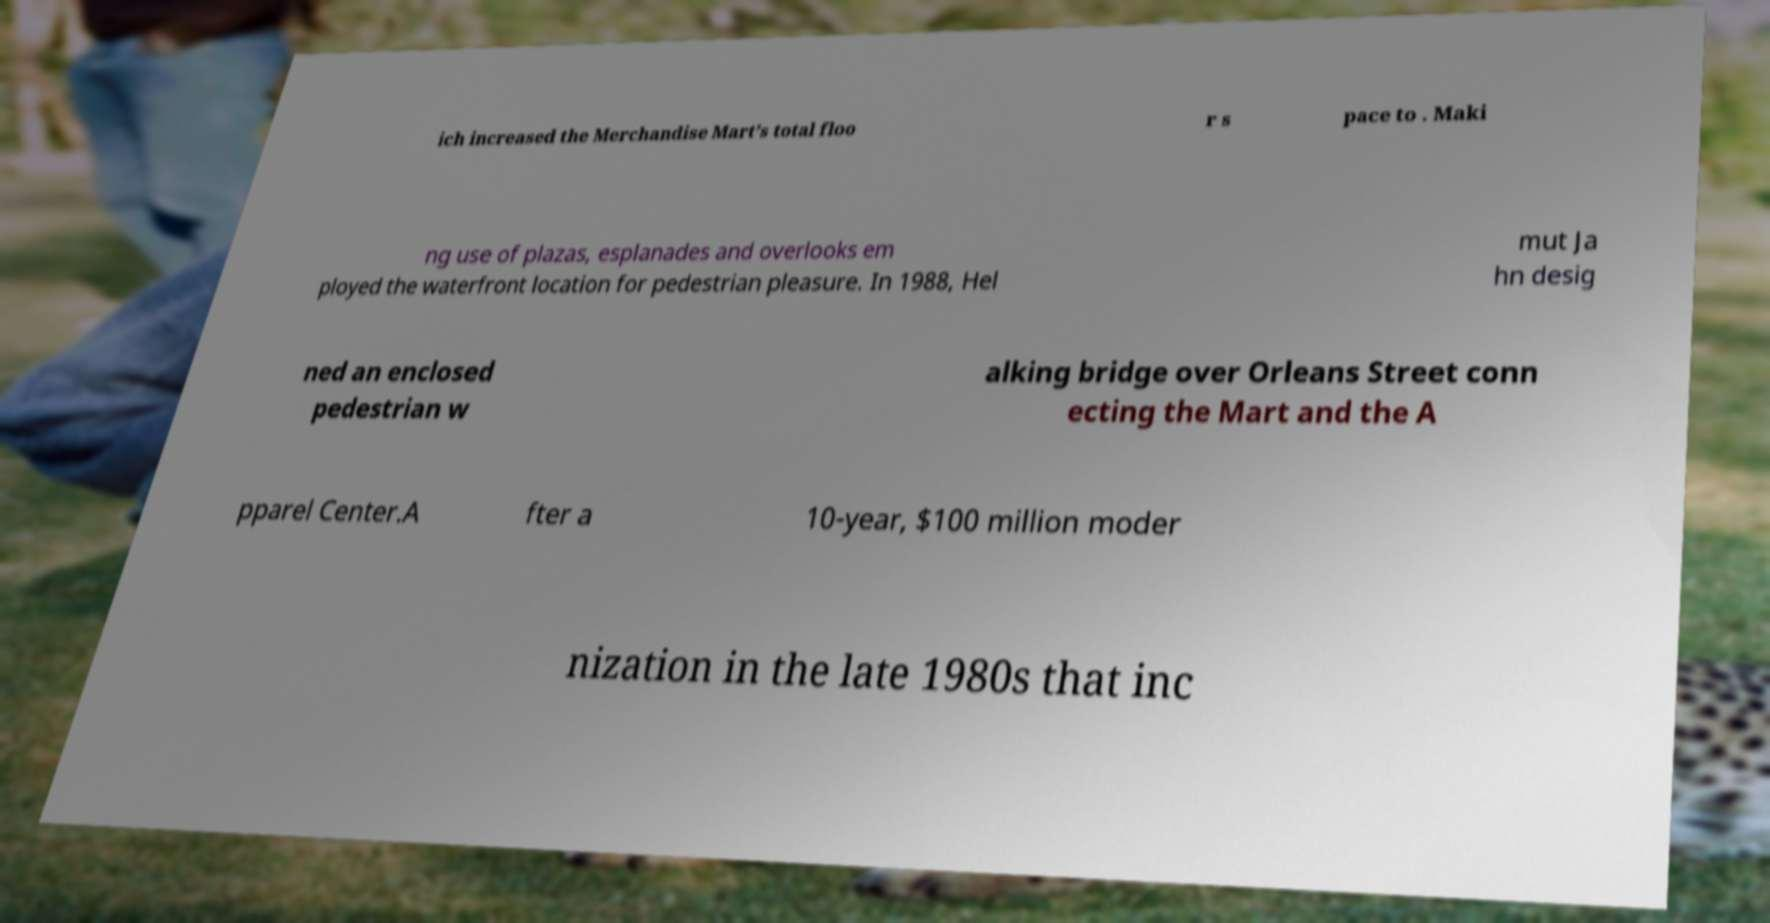There's text embedded in this image that I need extracted. Can you transcribe it verbatim? ich increased the Merchandise Mart’s total floo r s pace to . Maki ng use of plazas, esplanades and overlooks em ployed the waterfront location for pedestrian pleasure. In 1988, Hel mut Ja hn desig ned an enclosed pedestrian w alking bridge over Orleans Street conn ecting the Mart and the A pparel Center.A fter a 10-year, $100 million moder nization in the late 1980s that inc 